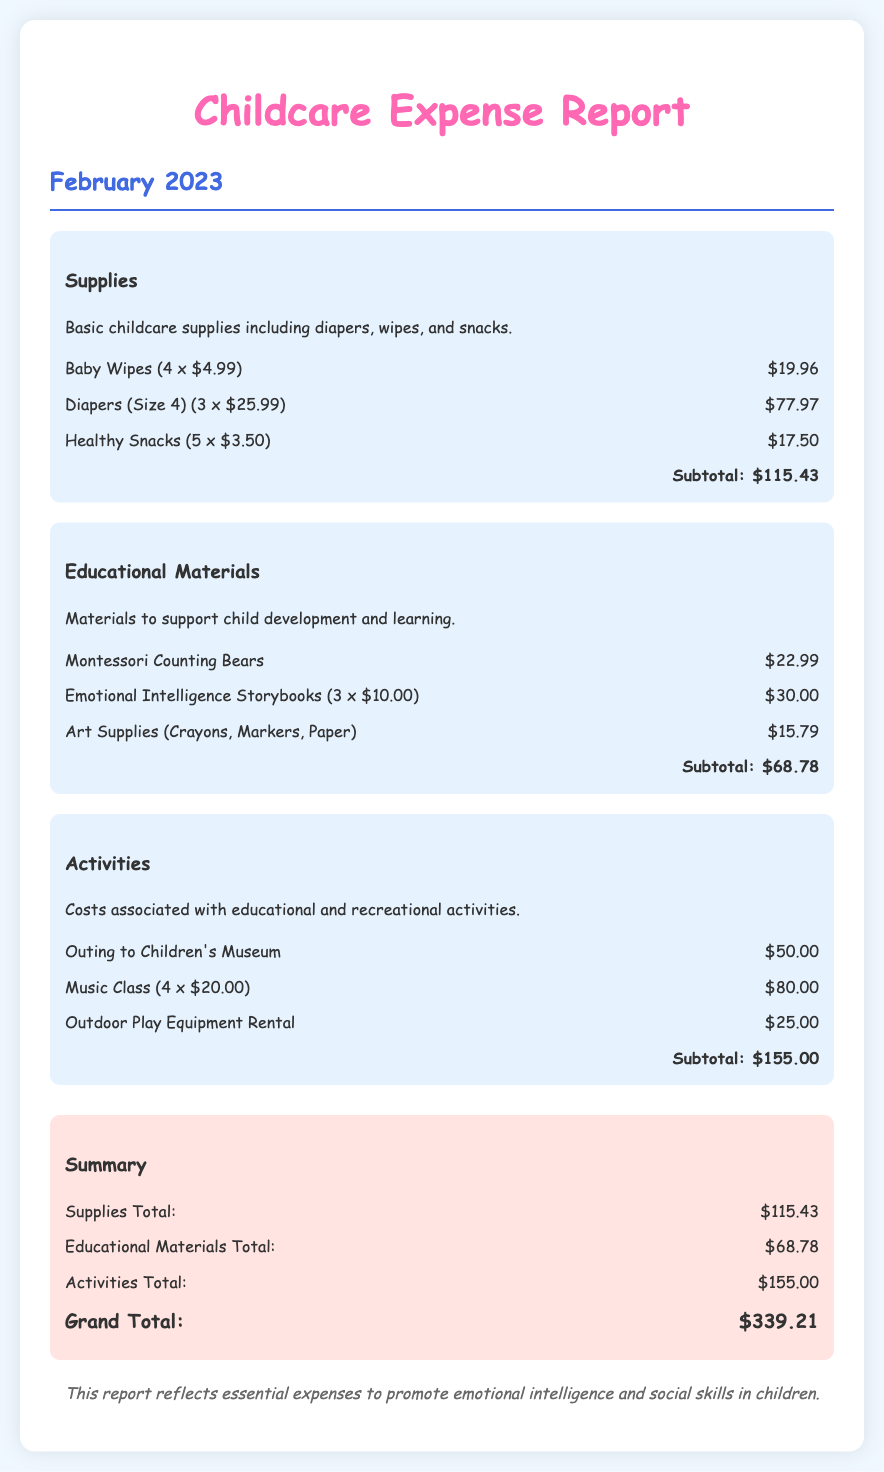what is the total cost for supplies? The total cost for supplies is detailed in the document under the Supplies category, which adds up to $115.43.
Answer: $115.43 how much did the Emotional Intelligence Storybooks cost? The cost of Emotional Intelligence Storybooks is listed as 3 x $10.00, which totals $30.00.
Answer: $30.00 what was the cost of the outing to the Children's Museum? The cost of the outing to the Children's Museum is specified as $50.00 under the Activities category.
Answer: $50.00 what is the subtotal for educational materials? The document states that the subtotal for educational materials is $68.78 after adding all the listed items.
Answer: $68.78 what is the grand total of expenses for February 2023? The grand total is listed at the end of the document, which is the sum of all categories, totaling $339.21.
Answer: $339.21 how many items were purchased under supplies? The document lists three items under the supplies category: Baby Wipes, Diapers, and Healthy Snacks.
Answer: 3 items which category has the highest expense? By comparing the subtotals of all categories, Activities has the highest expense at $155.00.
Answer: Activities what is the note at the bottom of the report? The note mentions that the report reflects essential expenses to promote emotional intelligence and social skills in children.
Answer: Emotional intelligence and social skills in children 